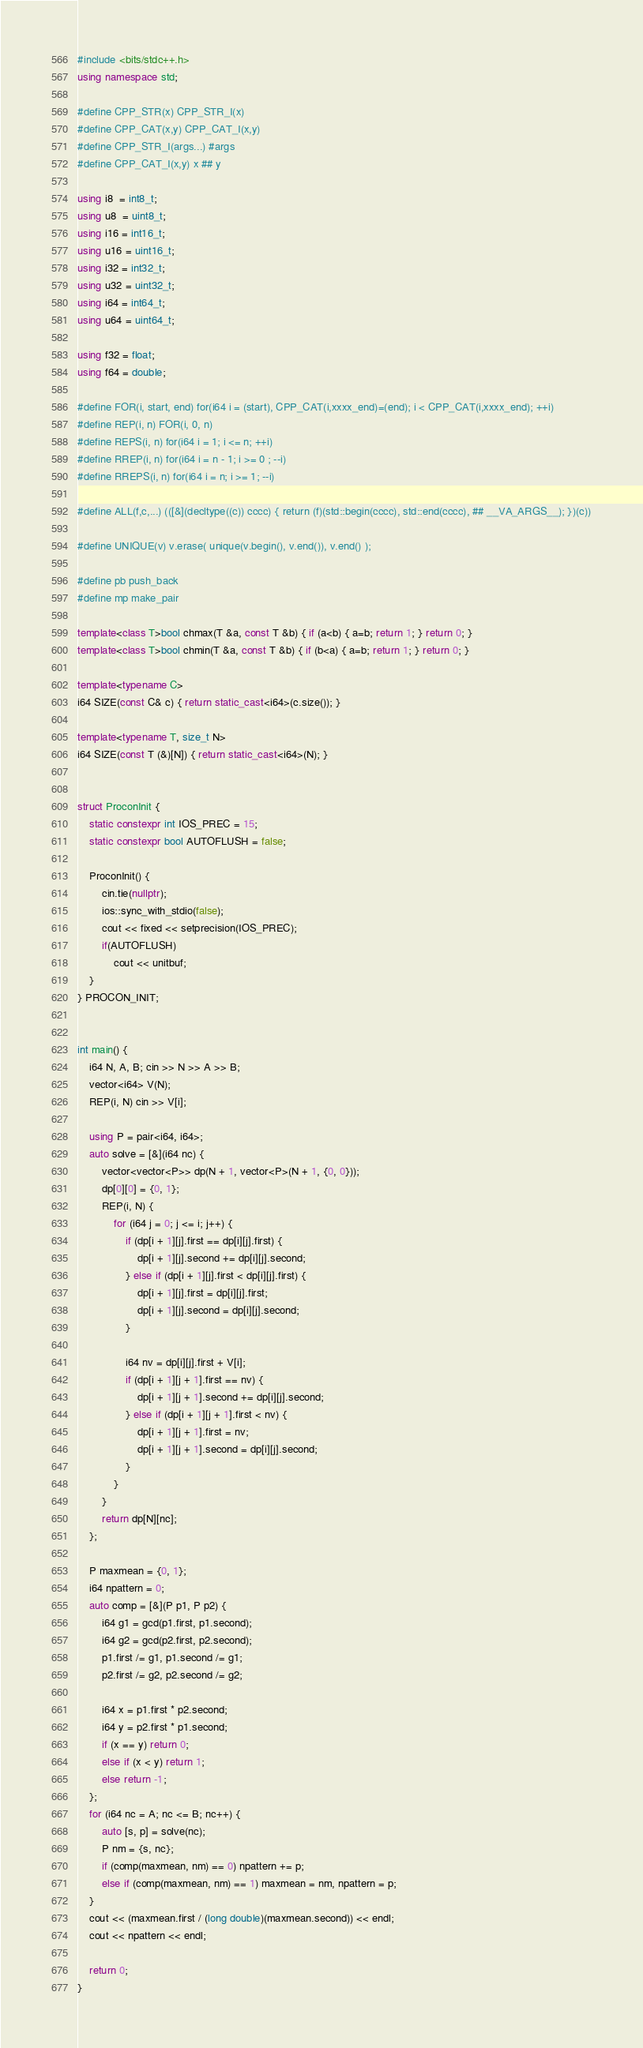<code> <loc_0><loc_0><loc_500><loc_500><_C++_>#include <bits/stdc++.h>
using namespace std;

#define CPP_STR(x) CPP_STR_I(x)
#define CPP_CAT(x,y) CPP_CAT_I(x,y)
#define CPP_STR_I(args...) #args
#define CPP_CAT_I(x,y) x ## y

using i8  = int8_t;
using u8  = uint8_t;
using i16 = int16_t;
using u16 = uint16_t;
using i32 = int32_t;
using u32 = uint32_t;
using i64 = int64_t;
using u64 = uint64_t;

using f32 = float;
using f64 = double;

#define FOR(i, start, end) for(i64 i = (start), CPP_CAT(i,xxxx_end)=(end); i < CPP_CAT(i,xxxx_end); ++i)
#define REP(i, n) FOR(i, 0, n)
#define REPS(i, n) for(i64 i = 1; i <= n; ++i)
#define RREP(i, n) for(i64 i = n - 1; i >= 0 ; --i)
#define RREPS(i, n) for(i64 i = n; i >= 1; --i)

#define ALL(f,c,...) (([&](decltype((c)) cccc) { return (f)(std::begin(cccc), std::end(cccc), ## __VA_ARGS__); })(c))

#define UNIQUE(v) v.erase( unique(v.begin(), v.end()), v.end() );

#define pb push_back
#define mp make_pair

template<class T>bool chmax(T &a, const T &b) { if (a<b) { a=b; return 1; } return 0; }
template<class T>bool chmin(T &a, const T &b) { if (b<a) { a=b; return 1; } return 0; }

template<typename C>
i64 SIZE(const C& c) { return static_cast<i64>(c.size()); }

template<typename T, size_t N>
i64 SIZE(const T (&)[N]) { return static_cast<i64>(N); }


struct ProconInit {
    static constexpr int IOS_PREC = 15;
    static constexpr bool AUTOFLUSH = false;

    ProconInit() {
        cin.tie(nullptr);
        ios::sync_with_stdio(false);
        cout << fixed << setprecision(IOS_PREC);
        if(AUTOFLUSH)
            cout << unitbuf;
    }
} PROCON_INIT;


int main() {
    i64 N, A, B; cin >> N >> A >> B;
    vector<i64> V(N);
    REP(i, N) cin >> V[i];

    using P = pair<i64, i64>;
    auto solve = [&](i64 nc) {
        vector<vector<P>> dp(N + 1, vector<P>(N + 1, {0, 0}));
        dp[0][0] = {0, 1};
        REP(i, N) {
            for (i64 j = 0; j <= i; j++) {
                if (dp[i + 1][j].first == dp[i][j].first) {
                    dp[i + 1][j].second += dp[i][j].second;
                } else if (dp[i + 1][j].first < dp[i][j].first) {
                    dp[i + 1][j].first = dp[i][j].first;
                    dp[i + 1][j].second = dp[i][j].second;
                }

                i64 nv = dp[i][j].first + V[i];
                if (dp[i + 1][j + 1].first == nv) {
                    dp[i + 1][j + 1].second += dp[i][j].second;
                } else if (dp[i + 1][j + 1].first < nv) {
                    dp[i + 1][j + 1].first = nv;
                    dp[i + 1][j + 1].second = dp[i][j].second;
                }
            }
        }
        return dp[N][nc];
    };

    P maxmean = {0, 1};
    i64 npattern = 0;
    auto comp = [&](P p1, P p2) {
        i64 g1 = gcd(p1.first, p1.second);
        i64 g2 = gcd(p2.first, p2.second);
        p1.first /= g1, p1.second /= g1;
        p2.first /= g2, p2.second /= g2;

        i64 x = p1.first * p2.second;
        i64 y = p2.first * p1.second;
        if (x == y) return 0;
        else if (x < y) return 1;
        else return -1;
    };
    for (i64 nc = A; nc <= B; nc++) {
        auto [s, p] = solve(nc);
        P nm = {s, nc};
        if (comp(maxmean, nm) == 0) npattern += p;
        else if (comp(maxmean, nm) == 1) maxmean = nm, npattern = p;
    }
    cout << (maxmean.first / (long double)(maxmean.second)) << endl;
    cout << npattern << endl;

    return 0;
}
</code> 